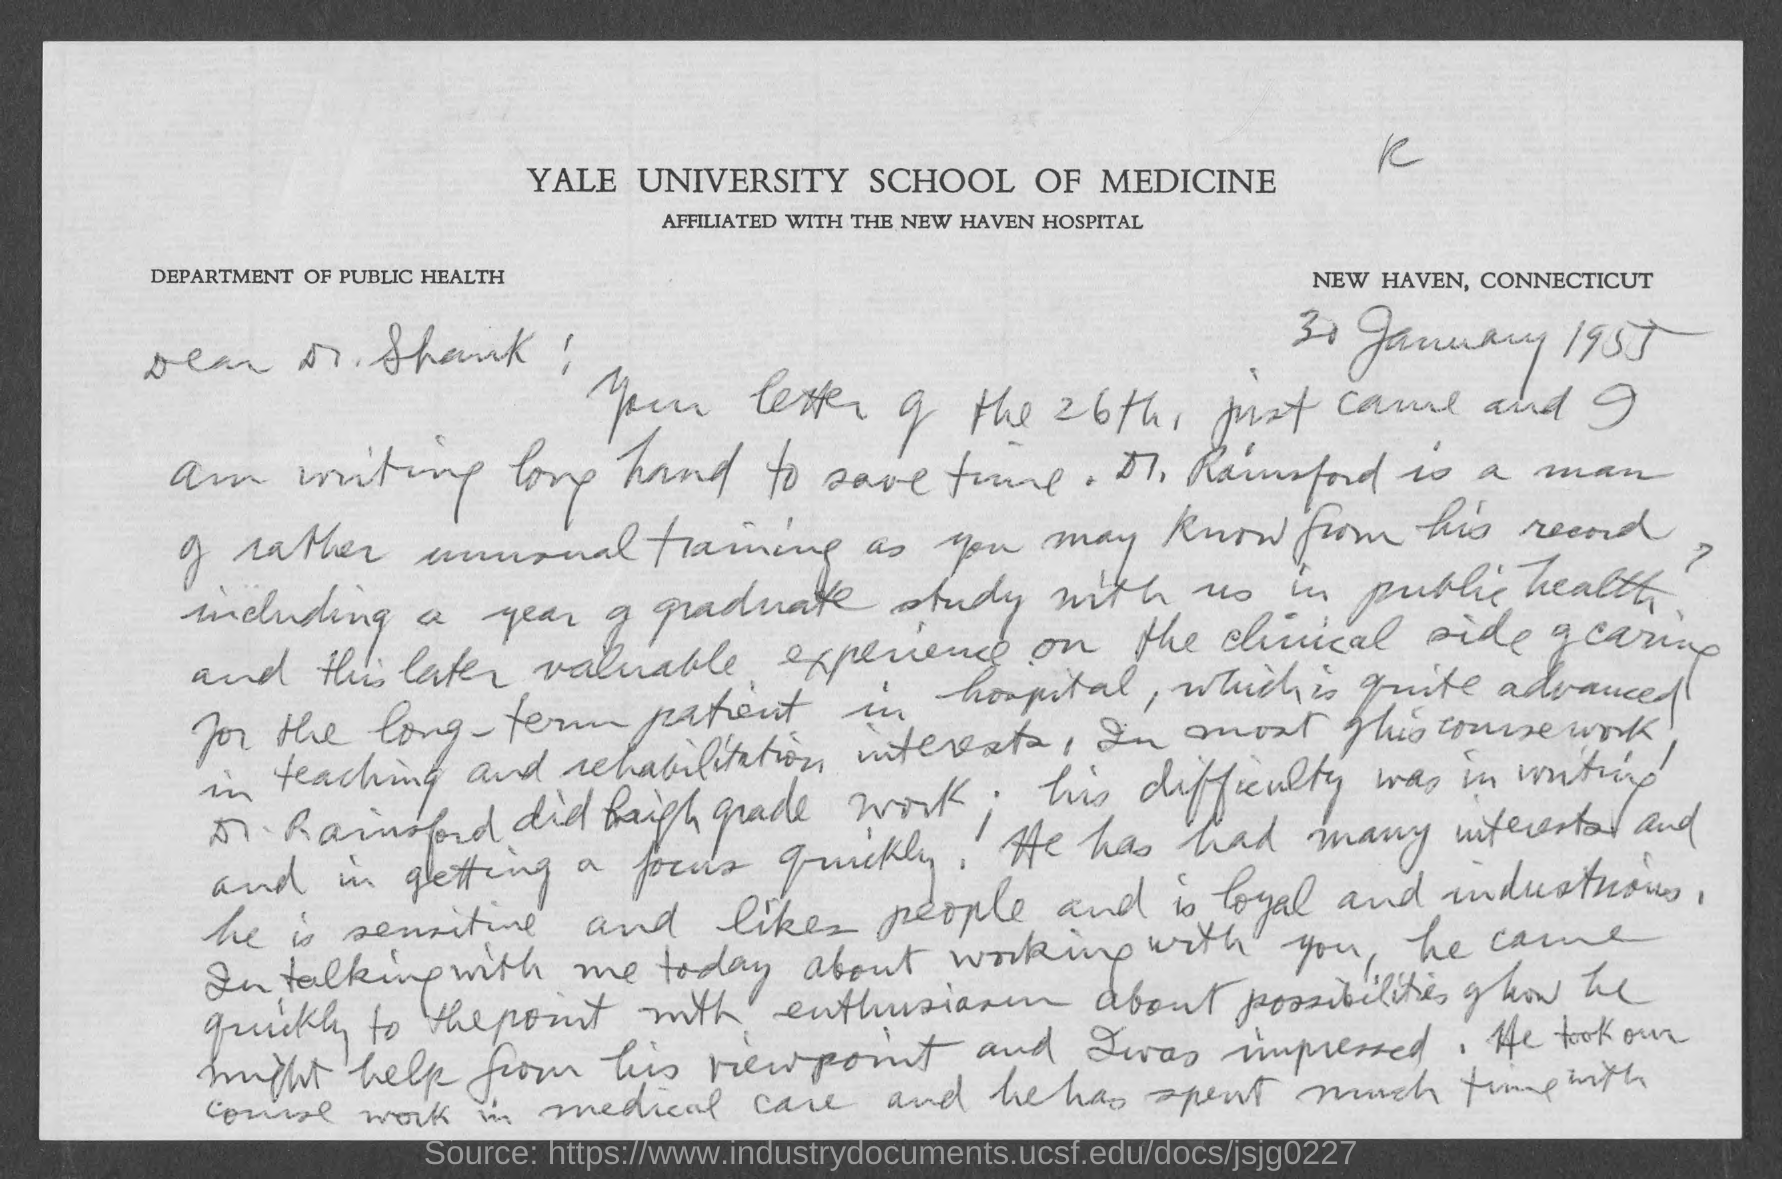What is the date on the document?
Keep it short and to the point. 30 January 1955. What is the Location on the letter?
Ensure brevity in your answer.  NEW HAVEN, CONNECTICUT. To Whom is this letter addressed to?
Make the answer very short. Dr. Shank. What is Yale university school of medicine affiliated to?
Provide a short and direct response. The New Haven Hospital. 